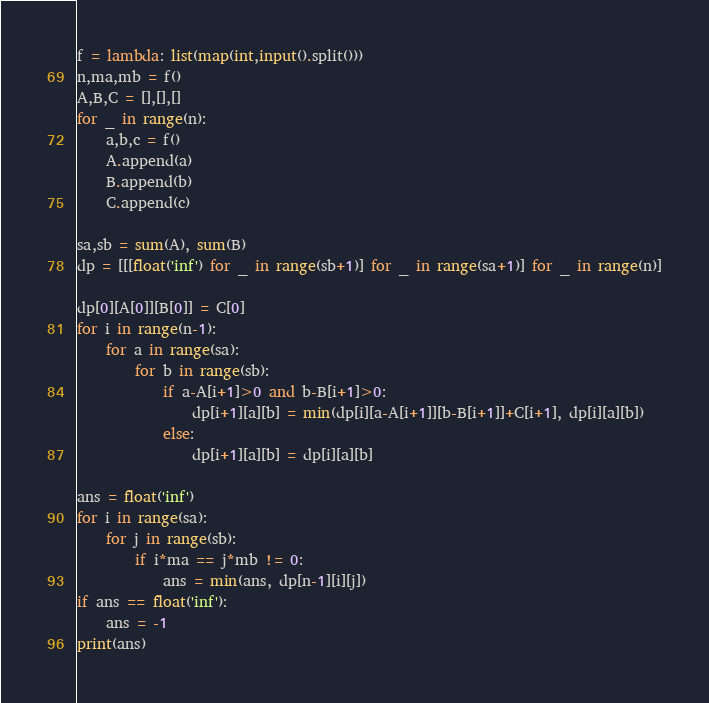<code> <loc_0><loc_0><loc_500><loc_500><_Python_>f = lambda: list(map(int,input().split()))
n,ma,mb = f()
A,B,C = [],[],[]
for _ in range(n):
    a,b,c = f()
    A.append(a)
    B.append(b)
    C.append(c)

sa,sb = sum(A), sum(B)
dp = [[[float('inf') for _ in range(sb+1)] for _ in range(sa+1)] for _ in range(n)]

dp[0][A[0]][B[0]] = C[0]
for i in range(n-1):
    for a in range(sa):
        for b in range(sb):
            if a-A[i+1]>0 and b-B[i+1]>0:
                dp[i+1][a][b] = min(dp[i][a-A[i+1]][b-B[i+1]]+C[i+1], dp[i][a][b])
            else:
                dp[i+1][a][b] = dp[i][a][b]

ans = float('inf')
for i in range(sa):
    for j in range(sb):
        if i*ma == j*mb != 0:
            ans = min(ans, dp[n-1][i][j])
if ans == float('inf'):
    ans = -1
print(ans)
</code> 